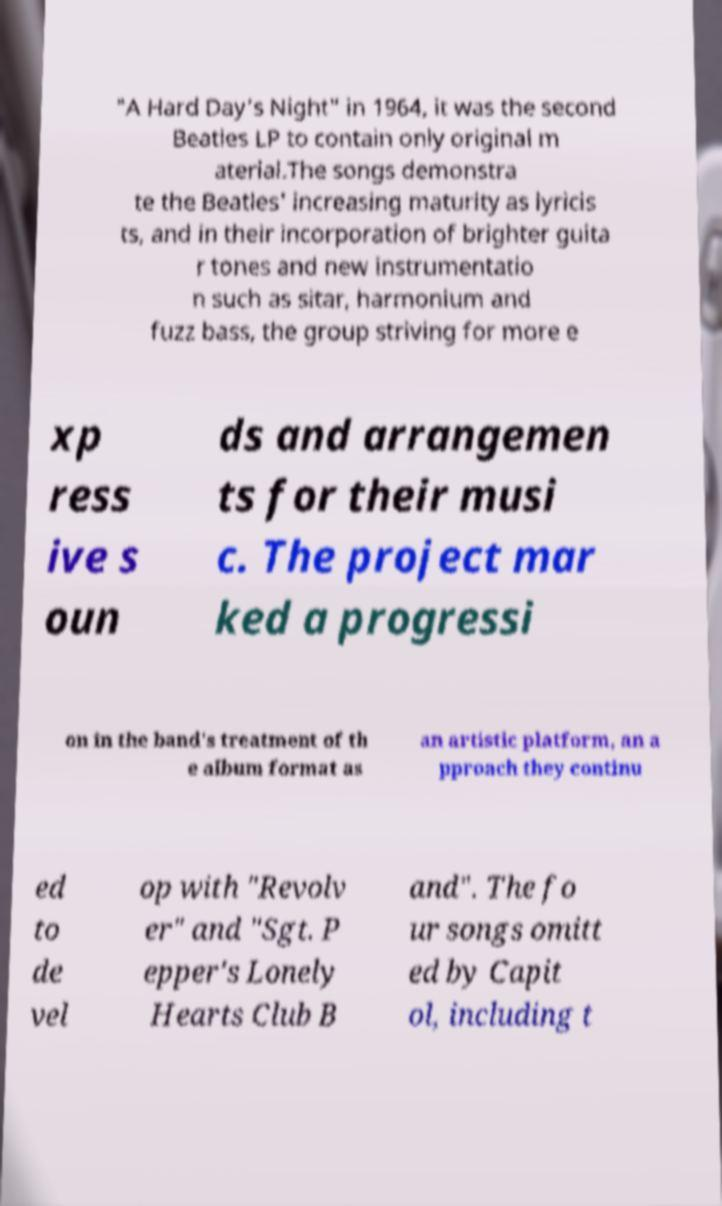For documentation purposes, I need the text within this image transcribed. Could you provide that? "A Hard Day's Night" in 1964, it was the second Beatles LP to contain only original m aterial.The songs demonstra te the Beatles' increasing maturity as lyricis ts, and in their incorporation of brighter guita r tones and new instrumentatio n such as sitar, harmonium and fuzz bass, the group striving for more e xp ress ive s oun ds and arrangemen ts for their musi c. The project mar ked a progressi on in the band's treatment of th e album format as an artistic platform, an a pproach they continu ed to de vel op with "Revolv er" and "Sgt. P epper's Lonely Hearts Club B and". The fo ur songs omitt ed by Capit ol, including t 